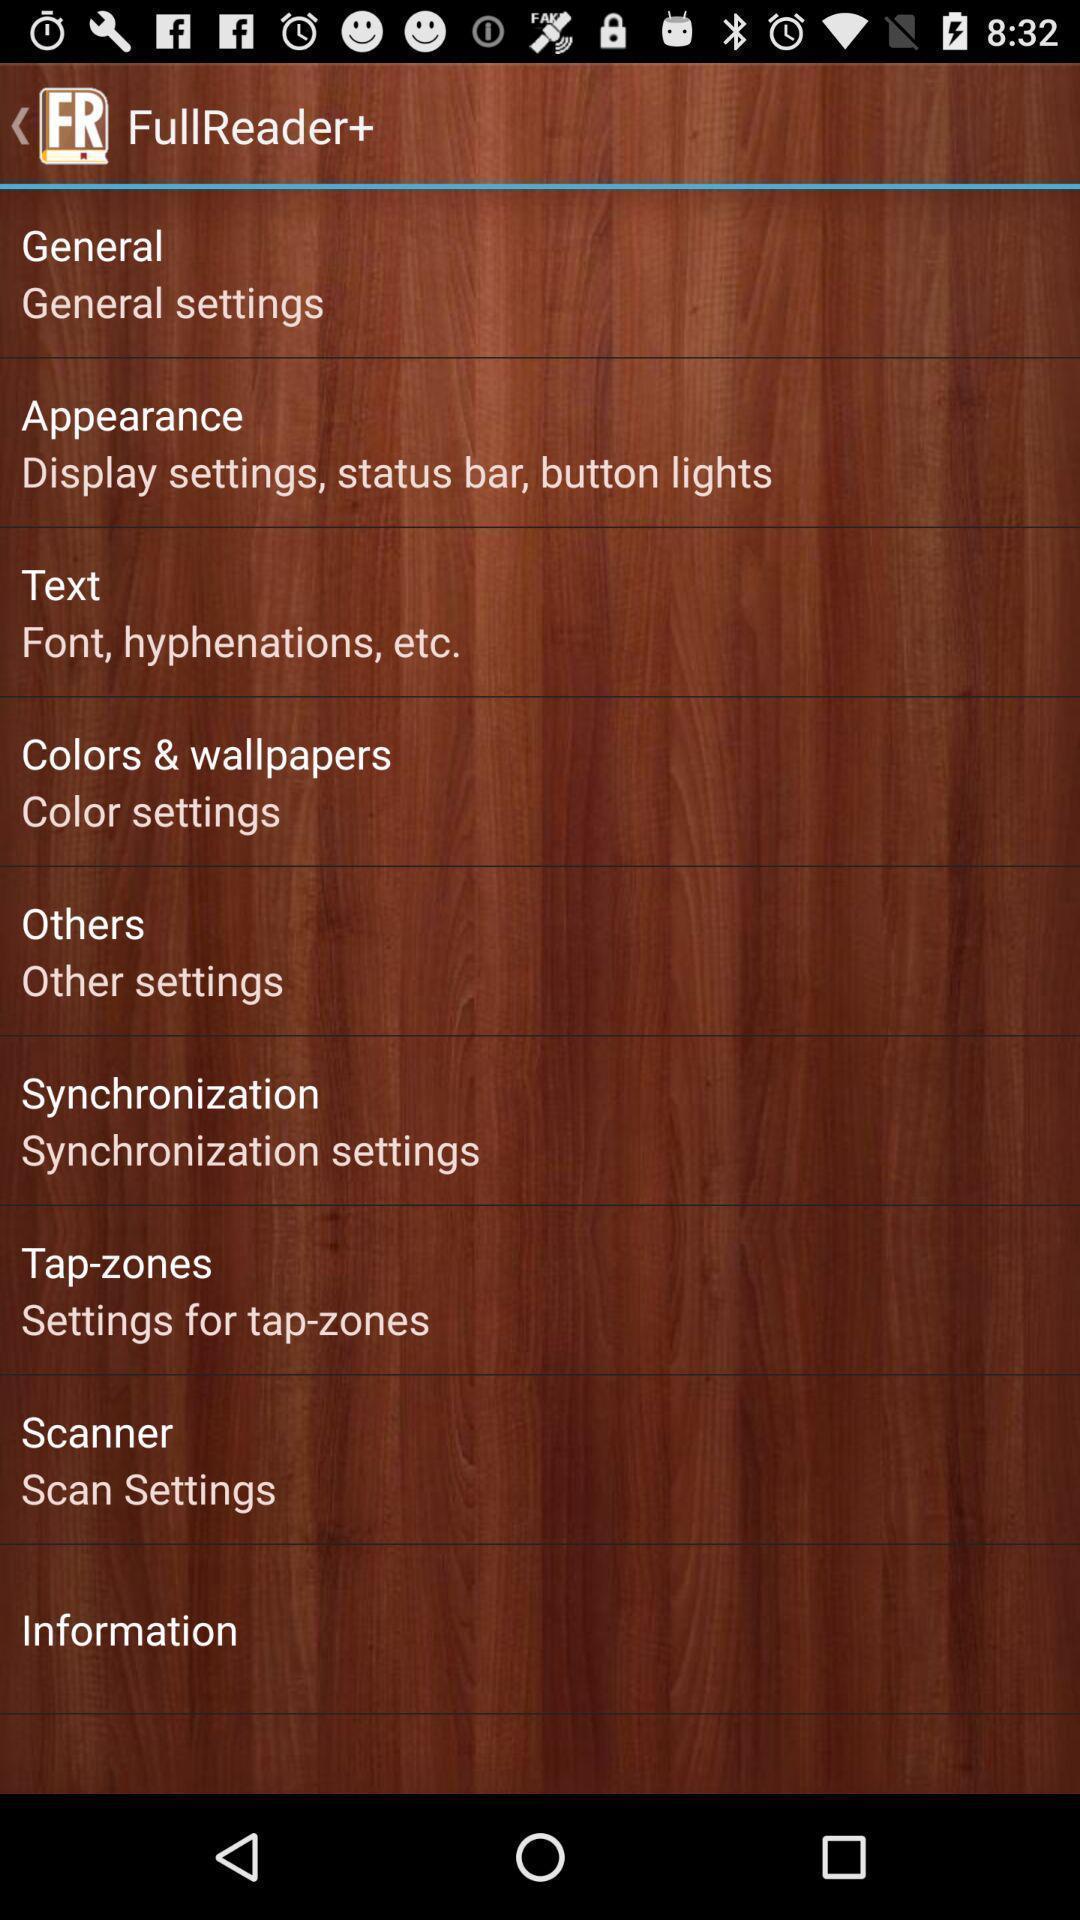Describe the key features of this screenshot. Settings page displayed. 